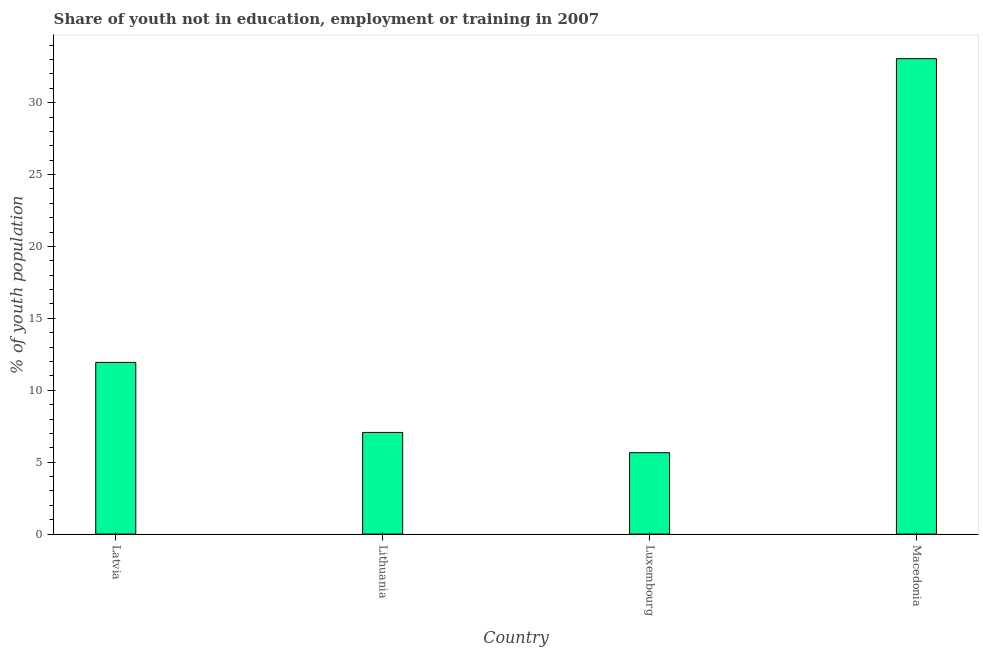What is the title of the graph?
Your answer should be compact. Share of youth not in education, employment or training in 2007. What is the label or title of the Y-axis?
Give a very brief answer. % of youth population. What is the unemployed youth population in Latvia?
Keep it short and to the point. 11.94. Across all countries, what is the maximum unemployed youth population?
Make the answer very short. 33.06. Across all countries, what is the minimum unemployed youth population?
Ensure brevity in your answer.  5.66. In which country was the unemployed youth population maximum?
Provide a succinct answer. Macedonia. In which country was the unemployed youth population minimum?
Make the answer very short. Luxembourg. What is the sum of the unemployed youth population?
Provide a short and direct response. 57.73. What is the difference between the unemployed youth population in Lithuania and Luxembourg?
Your answer should be very brief. 1.41. What is the average unemployed youth population per country?
Make the answer very short. 14.43. What is the median unemployed youth population?
Your answer should be compact. 9.5. In how many countries, is the unemployed youth population greater than 18 %?
Ensure brevity in your answer.  1. What is the ratio of the unemployed youth population in Latvia to that in Luxembourg?
Keep it short and to the point. 2.11. Is the unemployed youth population in Lithuania less than that in Macedonia?
Your answer should be compact. Yes. Is the difference between the unemployed youth population in Latvia and Lithuania greater than the difference between any two countries?
Offer a very short reply. No. What is the difference between the highest and the second highest unemployed youth population?
Your response must be concise. 21.12. Is the sum of the unemployed youth population in Lithuania and Macedonia greater than the maximum unemployed youth population across all countries?
Offer a very short reply. Yes. What is the difference between the highest and the lowest unemployed youth population?
Provide a short and direct response. 27.4. How many bars are there?
Make the answer very short. 4. What is the % of youth population in Latvia?
Your answer should be compact. 11.94. What is the % of youth population in Lithuania?
Make the answer very short. 7.07. What is the % of youth population in Luxembourg?
Provide a succinct answer. 5.66. What is the % of youth population in Macedonia?
Ensure brevity in your answer.  33.06. What is the difference between the % of youth population in Latvia and Lithuania?
Your answer should be very brief. 4.87. What is the difference between the % of youth population in Latvia and Luxembourg?
Keep it short and to the point. 6.28. What is the difference between the % of youth population in Latvia and Macedonia?
Ensure brevity in your answer.  -21.12. What is the difference between the % of youth population in Lithuania and Luxembourg?
Provide a succinct answer. 1.41. What is the difference between the % of youth population in Lithuania and Macedonia?
Your answer should be compact. -25.99. What is the difference between the % of youth population in Luxembourg and Macedonia?
Keep it short and to the point. -27.4. What is the ratio of the % of youth population in Latvia to that in Lithuania?
Your answer should be very brief. 1.69. What is the ratio of the % of youth population in Latvia to that in Luxembourg?
Keep it short and to the point. 2.11. What is the ratio of the % of youth population in Latvia to that in Macedonia?
Give a very brief answer. 0.36. What is the ratio of the % of youth population in Lithuania to that in Luxembourg?
Give a very brief answer. 1.25. What is the ratio of the % of youth population in Lithuania to that in Macedonia?
Offer a very short reply. 0.21. What is the ratio of the % of youth population in Luxembourg to that in Macedonia?
Provide a succinct answer. 0.17. 